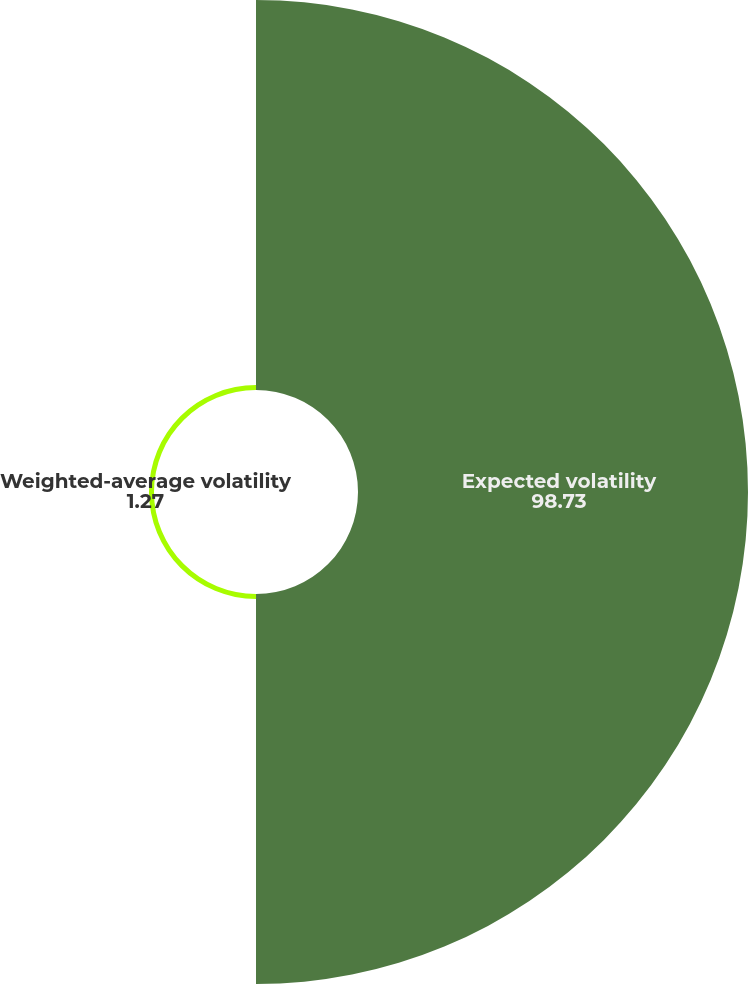Convert chart. <chart><loc_0><loc_0><loc_500><loc_500><pie_chart><fcel>Expected volatility<fcel>Weighted-average volatility<nl><fcel>98.73%<fcel>1.27%<nl></chart> 